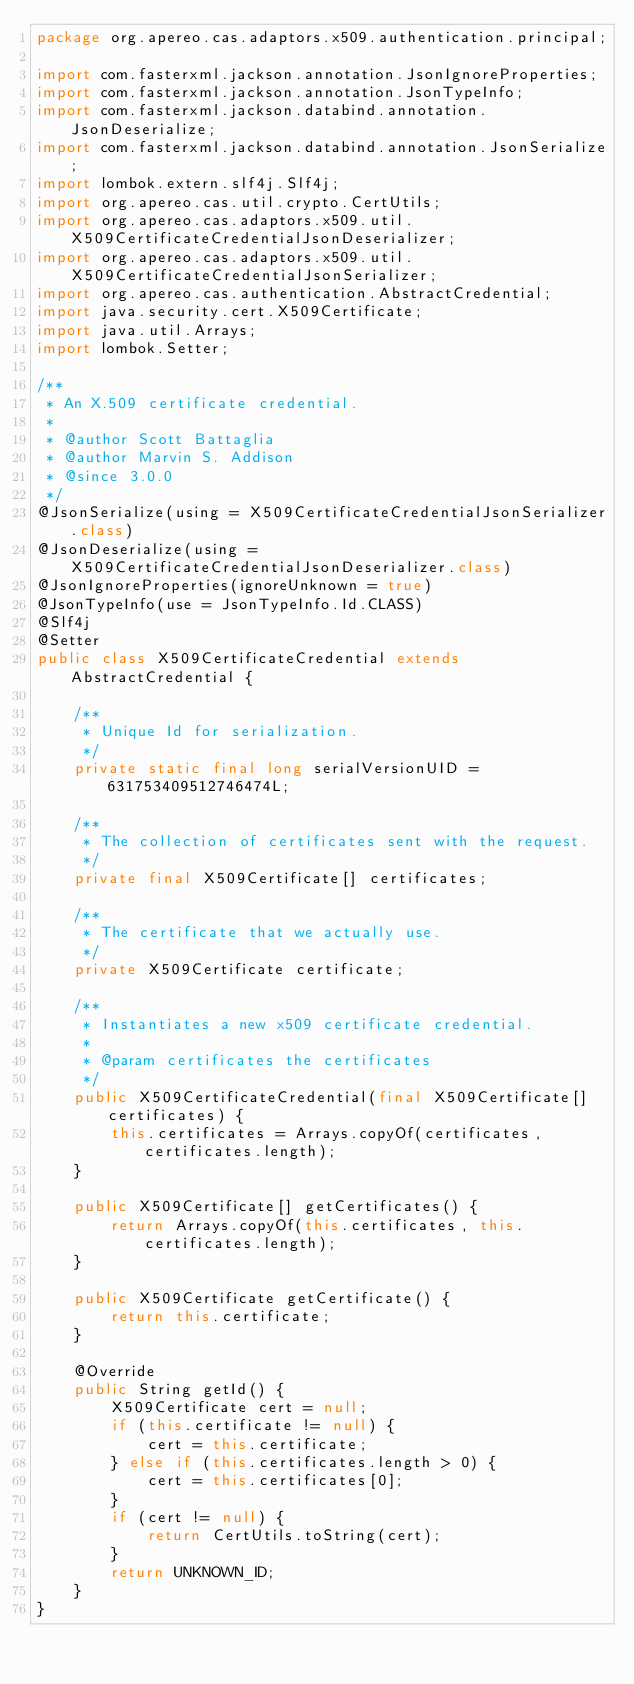<code> <loc_0><loc_0><loc_500><loc_500><_Java_>package org.apereo.cas.adaptors.x509.authentication.principal;

import com.fasterxml.jackson.annotation.JsonIgnoreProperties;
import com.fasterxml.jackson.annotation.JsonTypeInfo;
import com.fasterxml.jackson.databind.annotation.JsonDeserialize;
import com.fasterxml.jackson.databind.annotation.JsonSerialize;
import lombok.extern.slf4j.Slf4j;
import org.apereo.cas.util.crypto.CertUtils;
import org.apereo.cas.adaptors.x509.util.X509CertificateCredentialJsonDeserializer;
import org.apereo.cas.adaptors.x509.util.X509CertificateCredentialJsonSerializer;
import org.apereo.cas.authentication.AbstractCredential;
import java.security.cert.X509Certificate;
import java.util.Arrays;
import lombok.Setter;

/**
 * An X.509 certificate credential.
 *
 * @author Scott Battaglia
 * @author Marvin S. Addison
 * @since 3.0.0
 */
@JsonSerialize(using = X509CertificateCredentialJsonSerializer.class)
@JsonDeserialize(using = X509CertificateCredentialJsonDeserializer.class)
@JsonIgnoreProperties(ignoreUnknown = true)
@JsonTypeInfo(use = JsonTypeInfo.Id.CLASS)
@Slf4j
@Setter
public class X509CertificateCredential extends AbstractCredential {

    /**
     * Unique Id for serialization.
     */
    private static final long serialVersionUID = 631753409512746474L;

    /**
     * The collection of certificates sent with the request.
     */
    private final X509Certificate[] certificates;

    /**
     * The certificate that we actually use.
     */
    private X509Certificate certificate;

    /**
     * Instantiates a new x509 certificate credential.
     *
     * @param certificates the certificates
     */
    public X509CertificateCredential(final X509Certificate[] certificates) {
        this.certificates = Arrays.copyOf(certificates, certificates.length);
    }

    public X509Certificate[] getCertificates() {
        return Arrays.copyOf(this.certificates, this.certificates.length);
    }

    public X509Certificate getCertificate() {
        return this.certificate;
    }

    @Override
    public String getId() {
        X509Certificate cert = null;
        if (this.certificate != null) {
            cert = this.certificate;
        } else if (this.certificates.length > 0) {
            cert = this.certificates[0];
        }
        if (cert != null) {
            return CertUtils.toString(cert);
        }
        return UNKNOWN_ID;
    }
}
</code> 